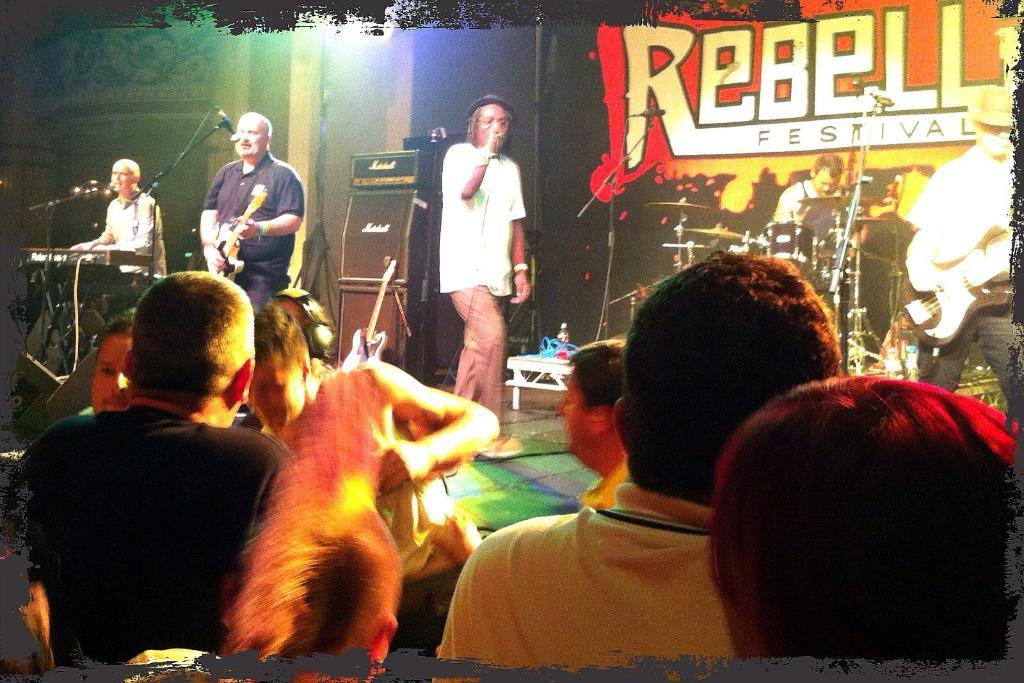What are the men in the image doing? The men in the image are playing musical instruments. Where are the men located in the image? The men are standing on a stage. Who else is present in the image besides the men on the stage? There are people in the image who are looking at the men on the stage. What type of horn is being used by the men on the stage? There is no horn visible in the image; the men are playing musical instruments, but no specific type of horn is mentioned. 